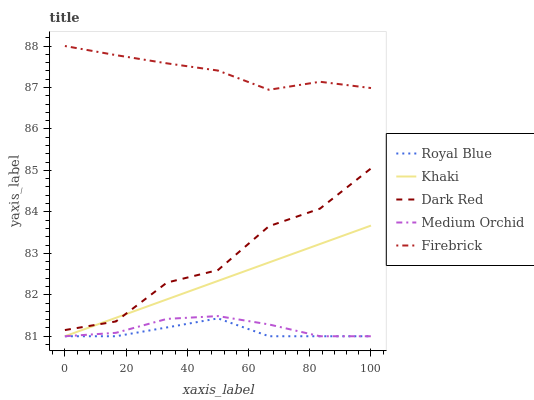Does Medium Orchid have the minimum area under the curve?
Answer yes or no. No. Does Medium Orchid have the maximum area under the curve?
Answer yes or no. No. Is Medium Orchid the smoothest?
Answer yes or no. No. Is Medium Orchid the roughest?
Answer yes or no. No. Does Firebrick have the lowest value?
Answer yes or no. No. Does Medium Orchid have the highest value?
Answer yes or no. No. Is Royal Blue less than Dark Red?
Answer yes or no. Yes. Is Firebrick greater than Khaki?
Answer yes or no. Yes. Does Royal Blue intersect Dark Red?
Answer yes or no. No. 